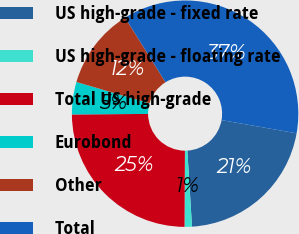<chart> <loc_0><loc_0><loc_500><loc_500><pie_chart><fcel>US high-grade - fixed rate<fcel>US high-grade - floating rate<fcel>Total US high-grade<fcel>Eurobond<fcel>Other<fcel>Total<nl><fcel>21.25%<fcel>1.05%<fcel>24.81%<fcel>4.62%<fcel>11.6%<fcel>36.66%<nl></chart> 